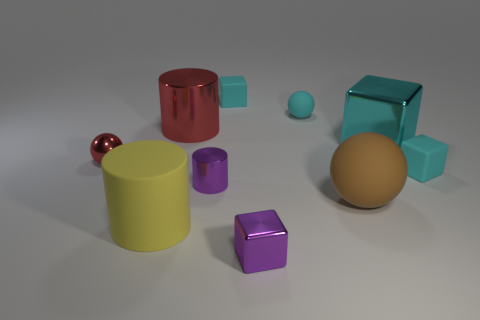There is a large object that is the same color as the small matte sphere; what is it made of?
Keep it short and to the point. Metal. The cyan matte object that is the same shape as the small red metal thing is what size?
Offer a very short reply. Small. Is the shape of the yellow object the same as the large red object?
Your answer should be compact. Yes. How many objects are either big matte cylinders that are to the right of the small red object or large red cubes?
Offer a terse response. 1. The cube that is made of the same material as the big cyan object is what size?
Make the answer very short. Small. How many things have the same color as the large shiny cylinder?
Make the answer very short. 1. What number of big objects are rubber cylinders or rubber spheres?
Provide a short and direct response. 2. What size is the thing that is the same color as the small metal ball?
Keep it short and to the point. Large. Is there a tiny purple block made of the same material as the small cylinder?
Offer a very short reply. Yes. What is the large cylinder that is behind the red ball made of?
Your answer should be very brief. Metal. 